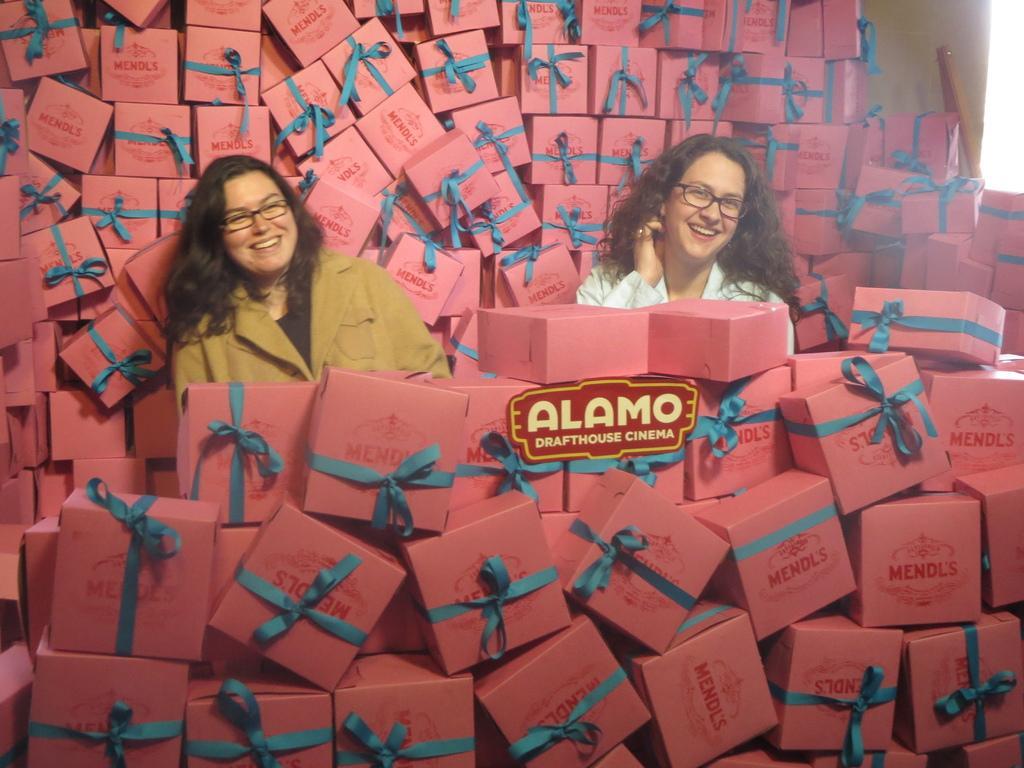Could you give a brief overview of what you see in this image? As we can see in the image there are two women and pink color boxes. The woman over here is wearing white color dress and the woman on the left side is wearing brown color dress. A ribbon is tied to boxes. 